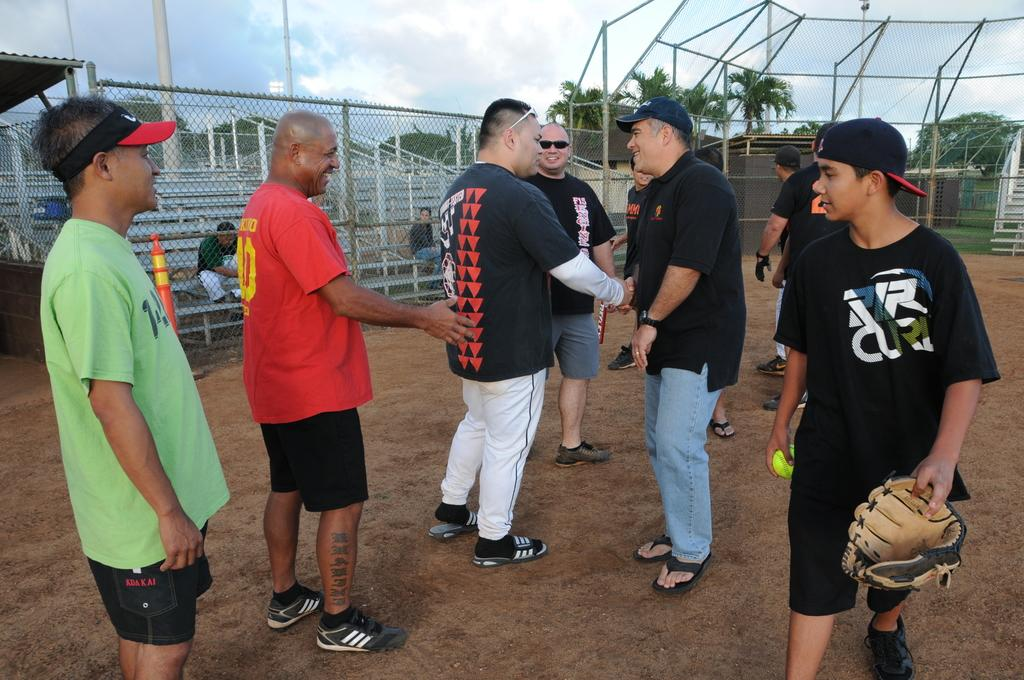Provide a one-sentence caption for the provided image. A group of guys on a baseball field and one wears a VR shirt. 